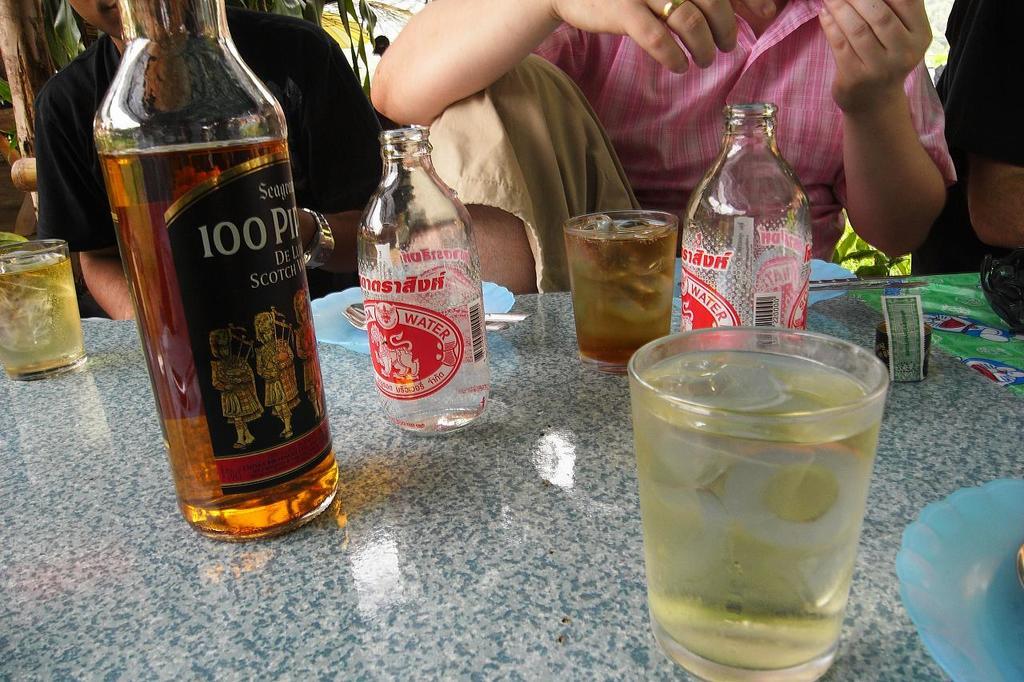How many bottles can be seen?
Make the answer very short. 3. 